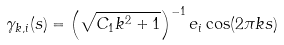<formula> <loc_0><loc_0><loc_500><loc_500>\gamma _ { k , i } ( s ) = \left ( \sqrt { C _ { 1 } k ^ { 2 } + 1 } \right ) ^ { - 1 } e _ { i } \cos ( 2 \pi k s )</formula> 